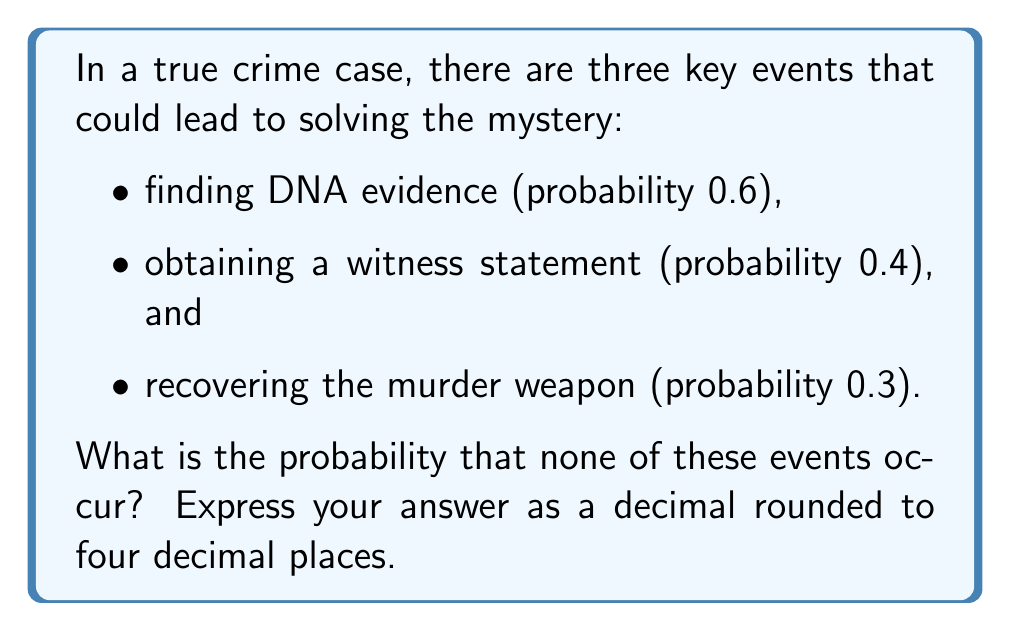Show me your answer to this math problem. Let's approach this step-by-step using polynomial multiplication:

1) First, we need to understand that the probability of an event not occurring is 1 minus the probability of it occurring.

2) So, let's define our probabilities:
   - Probability of not finding DNA evidence: $1 - 0.6 = 0.4$
   - Probability of not obtaining a witness statement: $1 - 0.4 = 0.6$
   - Probability of not recovering the murder weapon: $1 - 0.3 = 0.7$

3) Now, we want the probability of all these "not occurring" events happening together. In probability theory, when we want independent events to all occur, we multiply their individual probabilities.

4) We can represent this multiplication as a polynomial multiplication:

   $$(0.4 + 0.6x)(0.6 + 0.4x)(0.7 + 0.3x)$$

   Where $x$ is a dummy variable, and the constant term will give us our desired probability.

5) Let's multiply these out:

   $$(0.4 + 0.6x)(0.6 + 0.4x) = 0.24 + 0.36x + 0.24x + 0.24x^2 = 0.24 + 0.6x + 0.24x^2$$

6) Now multiply this result by $(0.7 + 0.3x)$:

   $$(0.24 + 0.6x + 0.24x^2)(0.7 + 0.3x)$$
   $$= 0.168 + 0.072x + 0.42x + 0.18x^2 + 0.168x^2 + 0.072x^3$$
   $$= 0.168 + 0.492x + 0.348x^2 + 0.072x^3$$

7) The constant term, 0.168, is our answer. This represents the probability that none of the three events occur.

8) Rounding to four decimal places: 0.1680
Answer: 0.1680 